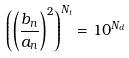<formula> <loc_0><loc_0><loc_500><loc_500>\left ( \left ( { \frac { b _ { n } } { a _ { n } } } \right ) ^ { 2 } \right ) ^ { N _ { t } } = 1 0 ^ { N _ { d } }</formula> 